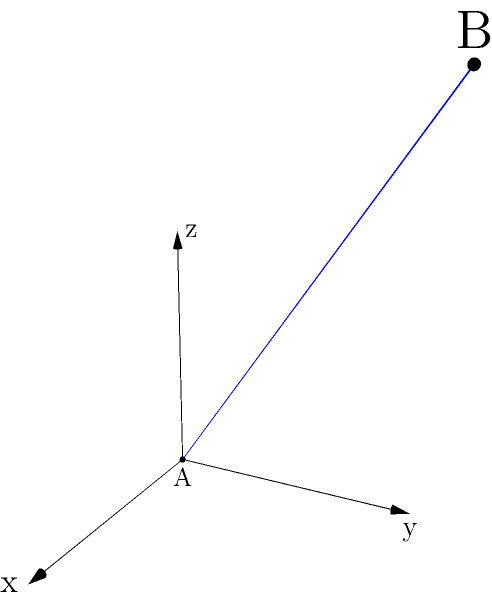In a high-energy particle physics experiment, two collision events are detected at different points in the detector's 3D coordinate system. Event A occurs at the origin (0, 0, 0), while event B is detected at coordinates (3, 4, 5) meters. Calculate the straight-line distance between these two events. How might this distance affect the interpretation of the collision data, considering the extremely short-lived nature of some particles produced in such collisions? To solve this problem, we'll use the three-dimensional distance formula, which is an extension of the Pythagorean theorem to 3D space.

1) The distance formula in 3D is:
   $$d = \sqrt{(x_2-x_1)^2 + (y_2-y_1)^2 + (z_2-z_1)^2}$$

2) We have:
   Point A: $(x_1, y_1, z_1) = (0, 0, 0)$
   Point B: $(x_2, y_2, z_2) = (3, 4, 5)$

3) Plugging these into the formula:
   $$d = \sqrt{(3-0)^2 + (4-0)^2 + (5-0)^2}$$

4) Simplify:
   $$d = \sqrt{3^2 + 4^2 + 5^2}$$

5) Calculate:
   $$d = \sqrt{9 + 16 + 25} = \sqrt{50} = 5\sqrt{2} \approx 7.07$$

6) Therefore, the distance between the two events is $5\sqrt{2}$ meters or approximately 7.07 meters.

Regarding the interpretation of collision data:
This distance is significant in particle physics experiments. Many particles produced in high-energy collisions have extremely short lifetimes, often on the order of $10^{-23}$ seconds or less. Even traveling at near the speed of light (3 × 10^8 m/s), these particles would only travel a fraction of a millimeter before decaying.

A distance of 7.07 meters between events suggests that:
a) These are likely two separate primary collision events, not a primary collision and a secondary decay.
b) Any short-lived particles produced in event A would have decayed long before reaching the location of event B.
c) The events are probably not causally connected, given the distance and the speed limit imposed by special relativity.

This distance helps physicists distinguish between different types of events and reconstruct the paths of longer-lived particles, which is crucial for understanding the outcomes of high-energy collisions.
Answer: $5\sqrt{2}$ meters 